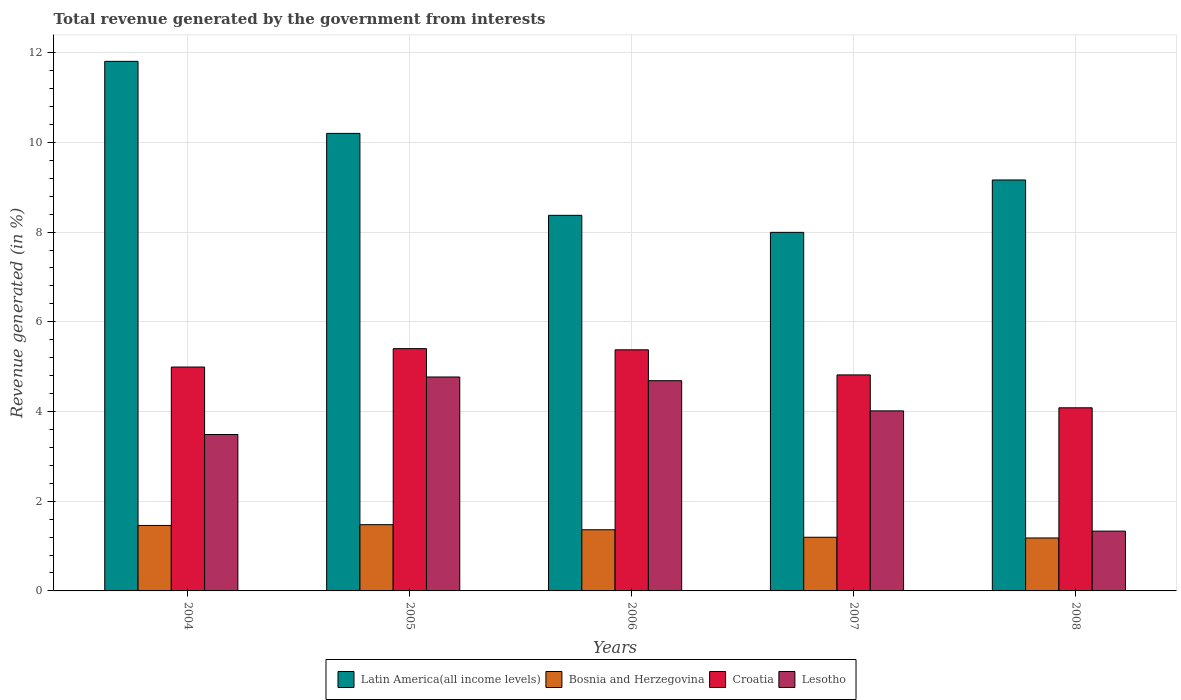How many different coloured bars are there?
Offer a very short reply. 4. Are the number of bars per tick equal to the number of legend labels?
Offer a very short reply. Yes. Are the number of bars on each tick of the X-axis equal?
Offer a very short reply. Yes. How many bars are there on the 2nd tick from the left?
Offer a very short reply. 4. What is the label of the 5th group of bars from the left?
Ensure brevity in your answer.  2008. In how many cases, is the number of bars for a given year not equal to the number of legend labels?
Your response must be concise. 0. What is the total revenue generated in Croatia in 2005?
Offer a terse response. 5.4. Across all years, what is the maximum total revenue generated in Latin America(all income levels)?
Provide a short and direct response. 11.81. Across all years, what is the minimum total revenue generated in Lesotho?
Your response must be concise. 1.33. What is the total total revenue generated in Croatia in the graph?
Ensure brevity in your answer.  24.67. What is the difference between the total revenue generated in Lesotho in 2004 and that in 2008?
Provide a short and direct response. 2.15. What is the difference between the total revenue generated in Croatia in 2007 and the total revenue generated in Latin America(all income levels) in 2006?
Provide a short and direct response. -3.56. What is the average total revenue generated in Bosnia and Herzegovina per year?
Provide a succinct answer. 1.34. In the year 2008, what is the difference between the total revenue generated in Bosnia and Herzegovina and total revenue generated in Latin America(all income levels)?
Provide a succinct answer. -7.98. In how many years, is the total revenue generated in Croatia greater than 7.2 %?
Keep it short and to the point. 0. What is the ratio of the total revenue generated in Croatia in 2005 to that in 2008?
Keep it short and to the point. 1.32. What is the difference between the highest and the second highest total revenue generated in Lesotho?
Provide a short and direct response. 0.08. What is the difference between the highest and the lowest total revenue generated in Latin America(all income levels)?
Your response must be concise. 3.81. In how many years, is the total revenue generated in Croatia greater than the average total revenue generated in Croatia taken over all years?
Offer a very short reply. 3. Is the sum of the total revenue generated in Lesotho in 2004 and 2008 greater than the maximum total revenue generated in Latin America(all income levels) across all years?
Your answer should be compact. No. What does the 4th bar from the left in 2006 represents?
Give a very brief answer. Lesotho. What does the 4th bar from the right in 2004 represents?
Ensure brevity in your answer.  Latin America(all income levels). Are all the bars in the graph horizontal?
Give a very brief answer. No. Are the values on the major ticks of Y-axis written in scientific E-notation?
Offer a terse response. No. Does the graph contain grids?
Offer a very short reply. Yes. What is the title of the graph?
Offer a terse response. Total revenue generated by the government from interests. Does "Panama" appear as one of the legend labels in the graph?
Provide a succinct answer. No. What is the label or title of the Y-axis?
Give a very brief answer. Revenue generated (in %). What is the Revenue generated (in %) of Latin America(all income levels) in 2004?
Provide a succinct answer. 11.81. What is the Revenue generated (in %) of Bosnia and Herzegovina in 2004?
Provide a succinct answer. 1.46. What is the Revenue generated (in %) in Croatia in 2004?
Provide a succinct answer. 4.99. What is the Revenue generated (in %) in Lesotho in 2004?
Offer a terse response. 3.49. What is the Revenue generated (in %) in Latin America(all income levels) in 2005?
Keep it short and to the point. 10.2. What is the Revenue generated (in %) in Bosnia and Herzegovina in 2005?
Offer a terse response. 1.48. What is the Revenue generated (in %) of Croatia in 2005?
Your response must be concise. 5.4. What is the Revenue generated (in %) in Lesotho in 2005?
Your response must be concise. 4.77. What is the Revenue generated (in %) in Latin America(all income levels) in 2006?
Your answer should be very brief. 8.37. What is the Revenue generated (in %) of Bosnia and Herzegovina in 2006?
Offer a very short reply. 1.36. What is the Revenue generated (in %) in Croatia in 2006?
Your response must be concise. 5.38. What is the Revenue generated (in %) in Lesotho in 2006?
Your answer should be very brief. 4.69. What is the Revenue generated (in %) in Latin America(all income levels) in 2007?
Provide a short and direct response. 7.99. What is the Revenue generated (in %) of Bosnia and Herzegovina in 2007?
Make the answer very short. 1.2. What is the Revenue generated (in %) in Croatia in 2007?
Offer a terse response. 4.82. What is the Revenue generated (in %) of Lesotho in 2007?
Your response must be concise. 4.01. What is the Revenue generated (in %) in Latin America(all income levels) in 2008?
Ensure brevity in your answer.  9.16. What is the Revenue generated (in %) of Bosnia and Herzegovina in 2008?
Offer a very short reply. 1.18. What is the Revenue generated (in %) in Croatia in 2008?
Ensure brevity in your answer.  4.08. What is the Revenue generated (in %) of Lesotho in 2008?
Your answer should be compact. 1.33. Across all years, what is the maximum Revenue generated (in %) of Latin America(all income levels)?
Make the answer very short. 11.81. Across all years, what is the maximum Revenue generated (in %) of Bosnia and Herzegovina?
Provide a short and direct response. 1.48. Across all years, what is the maximum Revenue generated (in %) in Croatia?
Make the answer very short. 5.4. Across all years, what is the maximum Revenue generated (in %) in Lesotho?
Offer a very short reply. 4.77. Across all years, what is the minimum Revenue generated (in %) of Latin America(all income levels)?
Offer a very short reply. 7.99. Across all years, what is the minimum Revenue generated (in %) in Bosnia and Herzegovina?
Make the answer very short. 1.18. Across all years, what is the minimum Revenue generated (in %) in Croatia?
Make the answer very short. 4.08. Across all years, what is the minimum Revenue generated (in %) of Lesotho?
Keep it short and to the point. 1.33. What is the total Revenue generated (in %) in Latin America(all income levels) in the graph?
Your answer should be compact. 47.54. What is the total Revenue generated (in %) in Bosnia and Herzegovina in the graph?
Your response must be concise. 6.68. What is the total Revenue generated (in %) of Croatia in the graph?
Keep it short and to the point. 24.67. What is the total Revenue generated (in %) of Lesotho in the graph?
Ensure brevity in your answer.  18.29. What is the difference between the Revenue generated (in %) of Latin America(all income levels) in 2004 and that in 2005?
Your answer should be very brief. 1.61. What is the difference between the Revenue generated (in %) of Bosnia and Herzegovina in 2004 and that in 2005?
Offer a very short reply. -0.02. What is the difference between the Revenue generated (in %) in Croatia in 2004 and that in 2005?
Keep it short and to the point. -0.41. What is the difference between the Revenue generated (in %) in Lesotho in 2004 and that in 2005?
Offer a very short reply. -1.28. What is the difference between the Revenue generated (in %) of Latin America(all income levels) in 2004 and that in 2006?
Your answer should be very brief. 3.43. What is the difference between the Revenue generated (in %) in Bosnia and Herzegovina in 2004 and that in 2006?
Make the answer very short. 0.1. What is the difference between the Revenue generated (in %) in Croatia in 2004 and that in 2006?
Keep it short and to the point. -0.38. What is the difference between the Revenue generated (in %) of Lesotho in 2004 and that in 2006?
Make the answer very short. -1.2. What is the difference between the Revenue generated (in %) of Latin America(all income levels) in 2004 and that in 2007?
Provide a short and direct response. 3.81. What is the difference between the Revenue generated (in %) in Bosnia and Herzegovina in 2004 and that in 2007?
Your answer should be very brief. 0.26. What is the difference between the Revenue generated (in %) in Croatia in 2004 and that in 2007?
Your answer should be compact. 0.18. What is the difference between the Revenue generated (in %) of Lesotho in 2004 and that in 2007?
Your answer should be compact. -0.53. What is the difference between the Revenue generated (in %) in Latin America(all income levels) in 2004 and that in 2008?
Keep it short and to the point. 2.64. What is the difference between the Revenue generated (in %) in Bosnia and Herzegovina in 2004 and that in 2008?
Keep it short and to the point. 0.28. What is the difference between the Revenue generated (in %) in Croatia in 2004 and that in 2008?
Your answer should be compact. 0.91. What is the difference between the Revenue generated (in %) of Lesotho in 2004 and that in 2008?
Your answer should be compact. 2.15. What is the difference between the Revenue generated (in %) of Latin America(all income levels) in 2005 and that in 2006?
Keep it short and to the point. 1.83. What is the difference between the Revenue generated (in %) of Bosnia and Herzegovina in 2005 and that in 2006?
Keep it short and to the point. 0.11. What is the difference between the Revenue generated (in %) in Croatia in 2005 and that in 2006?
Give a very brief answer. 0.03. What is the difference between the Revenue generated (in %) of Lesotho in 2005 and that in 2006?
Make the answer very short. 0.08. What is the difference between the Revenue generated (in %) in Latin America(all income levels) in 2005 and that in 2007?
Offer a terse response. 2.21. What is the difference between the Revenue generated (in %) in Bosnia and Herzegovina in 2005 and that in 2007?
Ensure brevity in your answer.  0.28. What is the difference between the Revenue generated (in %) in Croatia in 2005 and that in 2007?
Offer a very short reply. 0.59. What is the difference between the Revenue generated (in %) of Lesotho in 2005 and that in 2007?
Offer a terse response. 0.76. What is the difference between the Revenue generated (in %) of Bosnia and Herzegovina in 2005 and that in 2008?
Keep it short and to the point. 0.3. What is the difference between the Revenue generated (in %) in Croatia in 2005 and that in 2008?
Provide a short and direct response. 1.32. What is the difference between the Revenue generated (in %) in Lesotho in 2005 and that in 2008?
Your answer should be compact. 3.44. What is the difference between the Revenue generated (in %) of Latin America(all income levels) in 2006 and that in 2007?
Ensure brevity in your answer.  0.38. What is the difference between the Revenue generated (in %) of Bosnia and Herzegovina in 2006 and that in 2007?
Keep it short and to the point. 0.17. What is the difference between the Revenue generated (in %) of Croatia in 2006 and that in 2007?
Keep it short and to the point. 0.56. What is the difference between the Revenue generated (in %) of Lesotho in 2006 and that in 2007?
Offer a terse response. 0.67. What is the difference between the Revenue generated (in %) of Latin America(all income levels) in 2006 and that in 2008?
Your answer should be very brief. -0.79. What is the difference between the Revenue generated (in %) in Bosnia and Herzegovina in 2006 and that in 2008?
Make the answer very short. 0.18. What is the difference between the Revenue generated (in %) of Croatia in 2006 and that in 2008?
Give a very brief answer. 1.29. What is the difference between the Revenue generated (in %) of Lesotho in 2006 and that in 2008?
Your answer should be very brief. 3.35. What is the difference between the Revenue generated (in %) of Latin America(all income levels) in 2007 and that in 2008?
Your answer should be compact. -1.17. What is the difference between the Revenue generated (in %) of Bosnia and Herzegovina in 2007 and that in 2008?
Your response must be concise. 0.02. What is the difference between the Revenue generated (in %) in Croatia in 2007 and that in 2008?
Ensure brevity in your answer.  0.73. What is the difference between the Revenue generated (in %) in Lesotho in 2007 and that in 2008?
Your answer should be compact. 2.68. What is the difference between the Revenue generated (in %) in Latin America(all income levels) in 2004 and the Revenue generated (in %) in Bosnia and Herzegovina in 2005?
Provide a short and direct response. 10.33. What is the difference between the Revenue generated (in %) of Latin America(all income levels) in 2004 and the Revenue generated (in %) of Croatia in 2005?
Your response must be concise. 6.41. What is the difference between the Revenue generated (in %) in Latin America(all income levels) in 2004 and the Revenue generated (in %) in Lesotho in 2005?
Offer a very short reply. 7.04. What is the difference between the Revenue generated (in %) of Bosnia and Herzegovina in 2004 and the Revenue generated (in %) of Croatia in 2005?
Give a very brief answer. -3.94. What is the difference between the Revenue generated (in %) of Bosnia and Herzegovina in 2004 and the Revenue generated (in %) of Lesotho in 2005?
Provide a short and direct response. -3.31. What is the difference between the Revenue generated (in %) of Croatia in 2004 and the Revenue generated (in %) of Lesotho in 2005?
Provide a succinct answer. 0.22. What is the difference between the Revenue generated (in %) in Latin America(all income levels) in 2004 and the Revenue generated (in %) in Bosnia and Herzegovina in 2006?
Your response must be concise. 10.44. What is the difference between the Revenue generated (in %) of Latin America(all income levels) in 2004 and the Revenue generated (in %) of Croatia in 2006?
Offer a terse response. 6.43. What is the difference between the Revenue generated (in %) of Latin America(all income levels) in 2004 and the Revenue generated (in %) of Lesotho in 2006?
Your response must be concise. 7.12. What is the difference between the Revenue generated (in %) in Bosnia and Herzegovina in 2004 and the Revenue generated (in %) in Croatia in 2006?
Offer a terse response. -3.92. What is the difference between the Revenue generated (in %) of Bosnia and Herzegovina in 2004 and the Revenue generated (in %) of Lesotho in 2006?
Provide a short and direct response. -3.23. What is the difference between the Revenue generated (in %) of Croatia in 2004 and the Revenue generated (in %) of Lesotho in 2006?
Keep it short and to the point. 0.3. What is the difference between the Revenue generated (in %) in Latin America(all income levels) in 2004 and the Revenue generated (in %) in Bosnia and Herzegovina in 2007?
Make the answer very short. 10.61. What is the difference between the Revenue generated (in %) of Latin America(all income levels) in 2004 and the Revenue generated (in %) of Croatia in 2007?
Make the answer very short. 6.99. What is the difference between the Revenue generated (in %) in Latin America(all income levels) in 2004 and the Revenue generated (in %) in Lesotho in 2007?
Your answer should be very brief. 7.79. What is the difference between the Revenue generated (in %) in Bosnia and Herzegovina in 2004 and the Revenue generated (in %) in Croatia in 2007?
Offer a terse response. -3.36. What is the difference between the Revenue generated (in %) in Bosnia and Herzegovina in 2004 and the Revenue generated (in %) in Lesotho in 2007?
Provide a succinct answer. -2.55. What is the difference between the Revenue generated (in %) in Croatia in 2004 and the Revenue generated (in %) in Lesotho in 2007?
Give a very brief answer. 0.98. What is the difference between the Revenue generated (in %) in Latin America(all income levels) in 2004 and the Revenue generated (in %) in Bosnia and Herzegovina in 2008?
Your answer should be very brief. 10.63. What is the difference between the Revenue generated (in %) of Latin America(all income levels) in 2004 and the Revenue generated (in %) of Croatia in 2008?
Offer a very short reply. 7.72. What is the difference between the Revenue generated (in %) of Latin America(all income levels) in 2004 and the Revenue generated (in %) of Lesotho in 2008?
Your answer should be very brief. 10.47. What is the difference between the Revenue generated (in %) in Bosnia and Herzegovina in 2004 and the Revenue generated (in %) in Croatia in 2008?
Offer a terse response. -2.62. What is the difference between the Revenue generated (in %) in Bosnia and Herzegovina in 2004 and the Revenue generated (in %) in Lesotho in 2008?
Make the answer very short. 0.13. What is the difference between the Revenue generated (in %) of Croatia in 2004 and the Revenue generated (in %) of Lesotho in 2008?
Provide a succinct answer. 3.66. What is the difference between the Revenue generated (in %) of Latin America(all income levels) in 2005 and the Revenue generated (in %) of Bosnia and Herzegovina in 2006?
Provide a succinct answer. 8.84. What is the difference between the Revenue generated (in %) of Latin America(all income levels) in 2005 and the Revenue generated (in %) of Croatia in 2006?
Keep it short and to the point. 4.83. What is the difference between the Revenue generated (in %) in Latin America(all income levels) in 2005 and the Revenue generated (in %) in Lesotho in 2006?
Make the answer very short. 5.51. What is the difference between the Revenue generated (in %) of Bosnia and Herzegovina in 2005 and the Revenue generated (in %) of Croatia in 2006?
Offer a very short reply. -3.9. What is the difference between the Revenue generated (in %) of Bosnia and Herzegovina in 2005 and the Revenue generated (in %) of Lesotho in 2006?
Ensure brevity in your answer.  -3.21. What is the difference between the Revenue generated (in %) of Croatia in 2005 and the Revenue generated (in %) of Lesotho in 2006?
Your answer should be compact. 0.71. What is the difference between the Revenue generated (in %) in Latin America(all income levels) in 2005 and the Revenue generated (in %) in Bosnia and Herzegovina in 2007?
Your answer should be compact. 9. What is the difference between the Revenue generated (in %) of Latin America(all income levels) in 2005 and the Revenue generated (in %) of Croatia in 2007?
Provide a succinct answer. 5.38. What is the difference between the Revenue generated (in %) in Latin America(all income levels) in 2005 and the Revenue generated (in %) in Lesotho in 2007?
Make the answer very short. 6.19. What is the difference between the Revenue generated (in %) of Bosnia and Herzegovina in 2005 and the Revenue generated (in %) of Croatia in 2007?
Make the answer very short. -3.34. What is the difference between the Revenue generated (in %) in Bosnia and Herzegovina in 2005 and the Revenue generated (in %) in Lesotho in 2007?
Give a very brief answer. -2.54. What is the difference between the Revenue generated (in %) of Croatia in 2005 and the Revenue generated (in %) of Lesotho in 2007?
Your answer should be compact. 1.39. What is the difference between the Revenue generated (in %) of Latin America(all income levels) in 2005 and the Revenue generated (in %) of Bosnia and Herzegovina in 2008?
Offer a very short reply. 9.02. What is the difference between the Revenue generated (in %) in Latin America(all income levels) in 2005 and the Revenue generated (in %) in Croatia in 2008?
Provide a short and direct response. 6.12. What is the difference between the Revenue generated (in %) of Latin America(all income levels) in 2005 and the Revenue generated (in %) of Lesotho in 2008?
Give a very brief answer. 8.87. What is the difference between the Revenue generated (in %) of Bosnia and Herzegovina in 2005 and the Revenue generated (in %) of Croatia in 2008?
Give a very brief answer. -2.61. What is the difference between the Revenue generated (in %) in Bosnia and Herzegovina in 2005 and the Revenue generated (in %) in Lesotho in 2008?
Your response must be concise. 0.14. What is the difference between the Revenue generated (in %) in Croatia in 2005 and the Revenue generated (in %) in Lesotho in 2008?
Keep it short and to the point. 4.07. What is the difference between the Revenue generated (in %) in Latin America(all income levels) in 2006 and the Revenue generated (in %) in Bosnia and Herzegovina in 2007?
Provide a succinct answer. 7.18. What is the difference between the Revenue generated (in %) of Latin America(all income levels) in 2006 and the Revenue generated (in %) of Croatia in 2007?
Ensure brevity in your answer.  3.56. What is the difference between the Revenue generated (in %) of Latin America(all income levels) in 2006 and the Revenue generated (in %) of Lesotho in 2007?
Provide a short and direct response. 4.36. What is the difference between the Revenue generated (in %) of Bosnia and Herzegovina in 2006 and the Revenue generated (in %) of Croatia in 2007?
Your response must be concise. -3.45. What is the difference between the Revenue generated (in %) in Bosnia and Herzegovina in 2006 and the Revenue generated (in %) in Lesotho in 2007?
Offer a very short reply. -2.65. What is the difference between the Revenue generated (in %) in Croatia in 2006 and the Revenue generated (in %) in Lesotho in 2007?
Give a very brief answer. 1.36. What is the difference between the Revenue generated (in %) in Latin America(all income levels) in 2006 and the Revenue generated (in %) in Bosnia and Herzegovina in 2008?
Your response must be concise. 7.19. What is the difference between the Revenue generated (in %) in Latin America(all income levels) in 2006 and the Revenue generated (in %) in Croatia in 2008?
Provide a succinct answer. 4.29. What is the difference between the Revenue generated (in %) of Latin America(all income levels) in 2006 and the Revenue generated (in %) of Lesotho in 2008?
Your answer should be compact. 7.04. What is the difference between the Revenue generated (in %) of Bosnia and Herzegovina in 2006 and the Revenue generated (in %) of Croatia in 2008?
Provide a short and direct response. -2.72. What is the difference between the Revenue generated (in %) in Bosnia and Herzegovina in 2006 and the Revenue generated (in %) in Lesotho in 2008?
Provide a succinct answer. 0.03. What is the difference between the Revenue generated (in %) in Croatia in 2006 and the Revenue generated (in %) in Lesotho in 2008?
Offer a terse response. 4.04. What is the difference between the Revenue generated (in %) of Latin America(all income levels) in 2007 and the Revenue generated (in %) of Bosnia and Herzegovina in 2008?
Keep it short and to the point. 6.81. What is the difference between the Revenue generated (in %) in Latin America(all income levels) in 2007 and the Revenue generated (in %) in Croatia in 2008?
Offer a terse response. 3.91. What is the difference between the Revenue generated (in %) in Latin America(all income levels) in 2007 and the Revenue generated (in %) in Lesotho in 2008?
Provide a succinct answer. 6.66. What is the difference between the Revenue generated (in %) in Bosnia and Herzegovina in 2007 and the Revenue generated (in %) in Croatia in 2008?
Provide a succinct answer. -2.89. What is the difference between the Revenue generated (in %) of Bosnia and Herzegovina in 2007 and the Revenue generated (in %) of Lesotho in 2008?
Give a very brief answer. -0.14. What is the difference between the Revenue generated (in %) in Croatia in 2007 and the Revenue generated (in %) in Lesotho in 2008?
Give a very brief answer. 3.48. What is the average Revenue generated (in %) in Latin America(all income levels) per year?
Give a very brief answer. 9.51. What is the average Revenue generated (in %) in Bosnia and Herzegovina per year?
Provide a succinct answer. 1.34. What is the average Revenue generated (in %) in Croatia per year?
Offer a very short reply. 4.93. What is the average Revenue generated (in %) in Lesotho per year?
Ensure brevity in your answer.  3.66. In the year 2004, what is the difference between the Revenue generated (in %) of Latin America(all income levels) and Revenue generated (in %) of Bosnia and Herzegovina?
Offer a terse response. 10.35. In the year 2004, what is the difference between the Revenue generated (in %) of Latin America(all income levels) and Revenue generated (in %) of Croatia?
Offer a very short reply. 6.82. In the year 2004, what is the difference between the Revenue generated (in %) of Latin America(all income levels) and Revenue generated (in %) of Lesotho?
Make the answer very short. 8.32. In the year 2004, what is the difference between the Revenue generated (in %) of Bosnia and Herzegovina and Revenue generated (in %) of Croatia?
Your answer should be very brief. -3.53. In the year 2004, what is the difference between the Revenue generated (in %) of Bosnia and Herzegovina and Revenue generated (in %) of Lesotho?
Give a very brief answer. -2.03. In the year 2004, what is the difference between the Revenue generated (in %) of Croatia and Revenue generated (in %) of Lesotho?
Your answer should be compact. 1.5. In the year 2005, what is the difference between the Revenue generated (in %) of Latin America(all income levels) and Revenue generated (in %) of Bosnia and Herzegovina?
Make the answer very short. 8.72. In the year 2005, what is the difference between the Revenue generated (in %) in Latin America(all income levels) and Revenue generated (in %) in Croatia?
Offer a very short reply. 4.8. In the year 2005, what is the difference between the Revenue generated (in %) in Latin America(all income levels) and Revenue generated (in %) in Lesotho?
Provide a succinct answer. 5.43. In the year 2005, what is the difference between the Revenue generated (in %) in Bosnia and Herzegovina and Revenue generated (in %) in Croatia?
Provide a short and direct response. -3.93. In the year 2005, what is the difference between the Revenue generated (in %) in Bosnia and Herzegovina and Revenue generated (in %) in Lesotho?
Your response must be concise. -3.29. In the year 2005, what is the difference between the Revenue generated (in %) of Croatia and Revenue generated (in %) of Lesotho?
Your answer should be very brief. 0.63. In the year 2006, what is the difference between the Revenue generated (in %) in Latin America(all income levels) and Revenue generated (in %) in Bosnia and Herzegovina?
Provide a short and direct response. 7.01. In the year 2006, what is the difference between the Revenue generated (in %) in Latin America(all income levels) and Revenue generated (in %) in Croatia?
Provide a short and direct response. 3. In the year 2006, what is the difference between the Revenue generated (in %) of Latin America(all income levels) and Revenue generated (in %) of Lesotho?
Your answer should be very brief. 3.69. In the year 2006, what is the difference between the Revenue generated (in %) of Bosnia and Herzegovina and Revenue generated (in %) of Croatia?
Keep it short and to the point. -4.01. In the year 2006, what is the difference between the Revenue generated (in %) of Bosnia and Herzegovina and Revenue generated (in %) of Lesotho?
Offer a terse response. -3.32. In the year 2006, what is the difference between the Revenue generated (in %) in Croatia and Revenue generated (in %) in Lesotho?
Your answer should be compact. 0.69. In the year 2007, what is the difference between the Revenue generated (in %) of Latin America(all income levels) and Revenue generated (in %) of Bosnia and Herzegovina?
Your response must be concise. 6.8. In the year 2007, what is the difference between the Revenue generated (in %) of Latin America(all income levels) and Revenue generated (in %) of Croatia?
Provide a short and direct response. 3.18. In the year 2007, what is the difference between the Revenue generated (in %) in Latin America(all income levels) and Revenue generated (in %) in Lesotho?
Your answer should be very brief. 3.98. In the year 2007, what is the difference between the Revenue generated (in %) of Bosnia and Herzegovina and Revenue generated (in %) of Croatia?
Provide a short and direct response. -3.62. In the year 2007, what is the difference between the Revenue generated (in %) of Bosnia and Herzegovina and Revenue generated (in %) of Lesotho?
Provide a short and direct response. -2.82. In the year 2007, what is the difference between the Revenue generated (in %) of Croatia and Revenue generated (in %) of Lesotho?
Provide a short and direct response. 0.8. In the year 2008, what is the difference between the Revenue generated (in %) of Latin America(all income levels) and Revenue generated (in %) of Bosnia and Herzegovina?
Make the answer very short. 7.98. In the year 2008, what is the difference between the Revenue generated (in %) of Latin America(all income levels) and Revenue generated (in %) of Croatia?
Offer a terse response. 5.08. In the year 2008, what is the difference between the Revenue generated (in %) of Latin America(all income levels) and Revenue generated (in %) of Lesotho?
Keep it short and to the point. 7.83. In the year 2008, what is the difference between the Revenue generated (in %) of Bosnia and Herzegovina and Revenue generated (in %) of Croatia?
Give a very brief answer. -2.9. In the year 2008, what is the difference between the Revenue generated (in %) of Bosnia and Herzegovina and Revenue generated (in %) of Lesotho?
Give a very brief answer. -0.15. In the year 2008, what is the difference between the Revenue generated (in %) of Croatia and Revenue generated (in %) of Lesotho?
Offer a terse response. 2.75. What is the ratio of the Revenue generated (in %) of Latin America(all income levels) in 2004 to that in 2005?
Your response must be concise. 1.16. What is the ratio of the Revenue generated (in %) in Bosnia and Herzegovina in 2004 to that in 2005?
Provide a short and direct response. 0.99. What is the ratio of the Revenue generated (in %) in Croatia in 2004 to that in 2005?
Your response must be concise. 0.92. What is the ratio of the Revenue generated (in %) of Lesotho in 2004 to that in 2005?
Offer a very short reply. 0.73. What is the ratio of the Revenue generated (in %) in Latin America(all income levels) in 2004 to that in 2006?
Your response must be concise. 1.41. What is the ratio of the Revenue generated (in %) of Bosnia and Herzegovina in 2004 to that in 2006?
Provide a succinct answer. 1.07. What is the ratio of the Revenue generated (in %) in Croatia in 2004 to that in 2006?
Keep it short and to the point. 0.93. What is the ratio of the Revenue generated (in %) of Lesotho in 2004 to that in 2006?
Your response must be concise. 0.74. What is the ratio of the Revenue generated (in %) of Latin America(all income levels) in 2004 to that in 2007?
Provide a succinct answer. 1.48. What is the ratio of the Revenue generated (in %) of Bosnia and Herzegovina in 2004 to that in 2007?
Provide a succinct answer. 1.22. What is the ratio of the Revenue generated (in %) of Croatia in 2004 to that in 2007?
Give a very brief answer. 1.04. What is the ratio of the Revenue generated (in %) of Lesotho in 2004 to that in 2007?
Ensure brevity in your answer.  0.87. What is the ratio of the Revenue generated (in %) in Latin America(all income levels) in 2004 to that in 2008?
Give a very brief answer. 1.29. What is the ratio of the Revenue generated (in %) of Bosnia and Herzegovina in 2004 to that in 2008?
Keep it short and to the point. 1.24. What is the ratio of the Revenue generated (in %) in Croatia in 2004 to that in 2008?
Make the answer very short. 1.22. What is the ratio of the Revenue generated (in %) of Lesotho in 2004 to that in 2008?
Provide a short and direct response. 2.62. What is the ratio of the Revenue generated (in %) in Latin America(all income levels) in 2005 to that in 2006?
Your response must be concise. 1.22. What is the ratio of the Revenue generated (in %) in Bosnia and Herzegovina in 2005 to that in 2006?
Your answer should be very brief. 1.08. What is the ratio of the Revenue generated (in %) in Croatia in 2005 to that in 2006?
Your response must be concise. 1. What is the ratio of the Revenue generated (in %) of Lesotho in 2005 to that in 2006?
Provide a short and direct response. 1.02. What is the ratio of the Revenue generated (in %) in Latin America(all income levels) in 2005 to that in 2007?
Keep it short and to the point. 1.28. What is the ratio of the Revenue generated (in %) in Bosnia and Herzegovina in 2005 to that in 2007?
Give a very brief answer. 1.23. What is the ratio of the Revenue generated (in %) of Croatia in 2005 to that in 2007?
Provide a short and direct response. 1.12. What is the ratio of the Revenue generated (in %) of Lesotho in 2005 to that in 2007?
Your response must be concise. 1.19. What is the ratio of the Revenue generated (in %) in Latin America(all income levels) in 2005 to that in 2008?
Give a very brief answer. 1.11. What is the ratio of the Revenue generated (in %) of Bosnia and Herzegovina in 2005 to that in 2008?
Offer a very short reply. 1.25. What is the ratio of the Revenue generated (in %) of Croatia in 2005 to that in 2008?
Your answer should be very brief. 1.32. What is the ratio of the Revenue generated (in %) in Lesotho in 2005 to that in 2008?
Your response must be concise. 3.58. What is the ratio of the Revenue generated (in %) of Latin America(all income levels) in 2006 to that in 2007?
Provide a succinct answer. 1.05. What is the ratio of the Revenue generated (in %) in Bosnia and Herzegovina in 2006 to that in 2007?
Your response must be concise. 1.14. What is the ratio of the Revenue generated (in %) in Croatia in 2006 to that in 2007?
Your answer should be very brief. 1.12. What is the ratio of the Revenue generated (in %) in Lesotho in 2006 to that in 2007?
Keep it short and to the point. 1.17. What is the ratio of the Revenue generated (in %) of Latin America(all income levels) in 2006 to that in 2008?
Ensure brevity in your answer.  0.91. What is the ratio of the Revenue generated (in %) of Bosnia and Herzegovina in 2006 to that in 2008?
Provide a succinct answer. 1.16. What is the ratio of the Revenue generated (in %) in Croatia in 2006 to that in 2008?
Your answer should be compact. 1.32. What is the ratio of the Revenue generated (in %) in Lesotho in 2006 to that in 2008?
Your response must be concise. 3.51. What is the ratio of the Revenue generated (in %) in Latin America(all income levels) in 2007 to that in 2008?
Offer a very short reply. 0.87. What is the ratio of the Revenue generated (in %) of Bosnia and Herzegovina in 2007 to that in 2008?
Provide a short and direct response. 1.01. What is the ratio of the Revenue generated (in %) of Croatia in 2007 to that in 2008?
Keep it short and to the point. 1.18. What is the ratio of the Revenue generated (in %) of Lesotho in 2007 to that in 2008?
Provide a succinct answer. 3.01. What is the difference between the highest and the second highest Revenue generated (in %) of Latin America(all income levels)?
Make the answer very short. 1.61. What is the difference between the highest and the second highest Revenue generated (in %) of Bosnia and Herzegovina?
Offer a very short reply. 0.02. What is the difference between the highest and the second highest Revenue generated (in %) in Croatia?
Offer a terse response. 0.03. What is the difference between the highest and the second highest Revenue generated (in %) of Lesotho?
Offer a very short reply. 0.08. What is the difference between the highest and the lowest Revenue generated (in %) of Latin America(all income levels)?
Provide a succinct answer. 3.81. What is the difference between the highest and the lowest Revenue generated (in %) of Bosnia and Herzegovina?
Offer a very short reply. 0.3. What is the difference between the highest and the lowest Revenue generated (in %) of Croatia?
Offer a terse response. 1.32. What is the difference between the highest and the lowest Revenue generated (in %) in Lesotho?
Give a very brief answer. 3.44. 